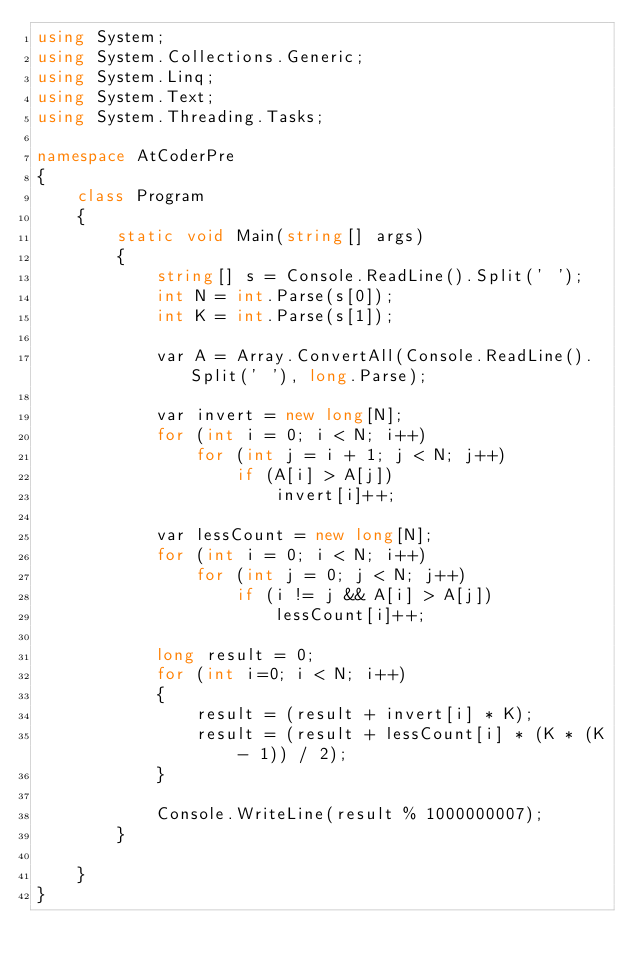<code> <loc_0><loc_0><loc_500><loc_500><_C#_>using System;
using System.Collections.Generic;
using System.Linq;
using System.Text;
using System.Threading.Tasks;

namespace AtCoderPre
{
    class Program
    {
        static void Main(string[] args)
        {
            string[] s = Console.ReadLine().Split(' ');
            int N = int.Parse(s[0]);
            int K = int.Parse(s[1]);
             
            var A = Array.ConvertAll(Console.ReadLine().Split(' '), long.Parse);

            var invert = new long[N];
            for (int i = 0; i < N; i++)
                for (int j = i + 1; j < N; j++)
                    if (A[i] > A[j])
                        invert[i]++;

            var lessCount = new long[N];
            for (int i = 0; i < N; i++)
                for (int j = 0; j < N; j++)
                    if (i != j && A[i] > A[j])
                        lessCount[i]++;

            long result = 0;
            for (int i=0; i < N; i++)
            {
                result = (result + invert[i] * K);
                result = (result + lessCount[i] * (K * (K - 1)) / 2);
            }

            Console.WriteLine(result % 1000000007);
        }

    }
}

</code> 